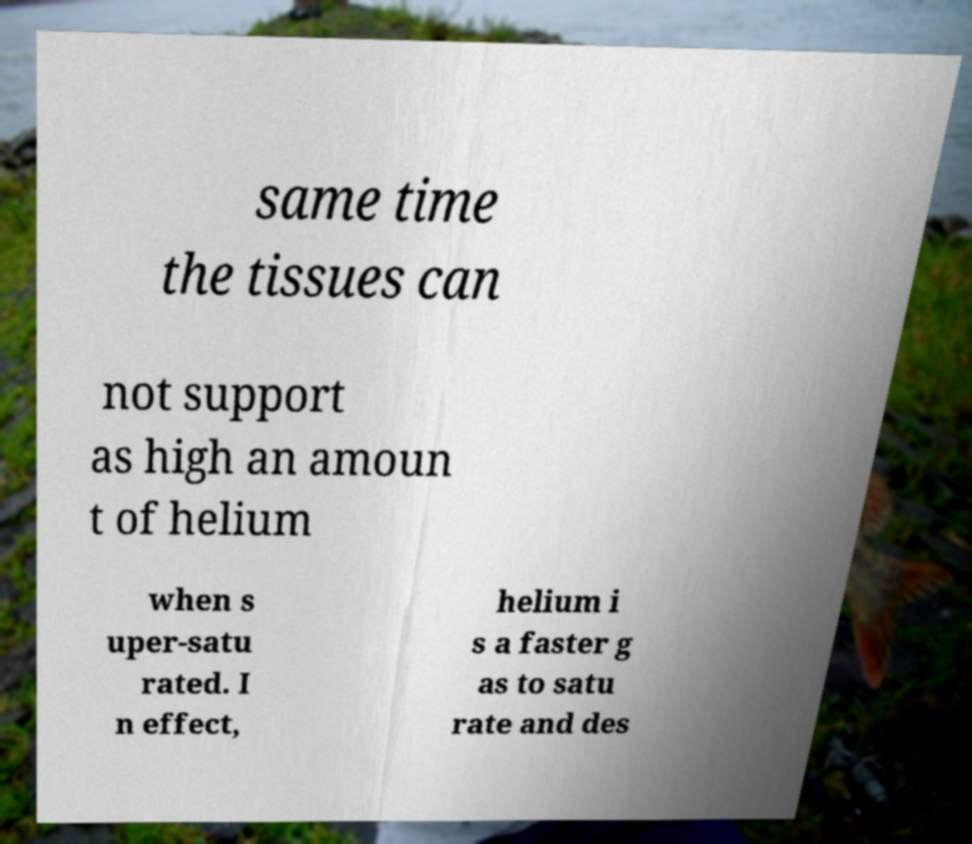I need the written content from this picture converted into text. Can you do that? same time the tissues can not support as high an amoun t of helium when s uper-satu rated. I n effect, helium i s a faster g as to satu rate and des 